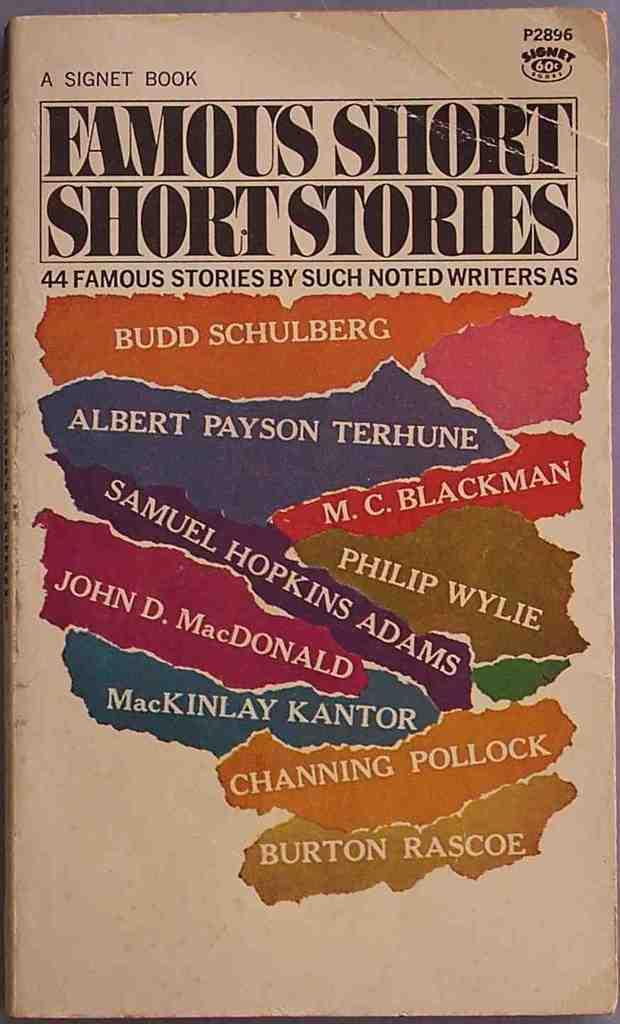<image>
Share a concise interpretation of the image provided. The cover of a book of Famous Short Stories. 